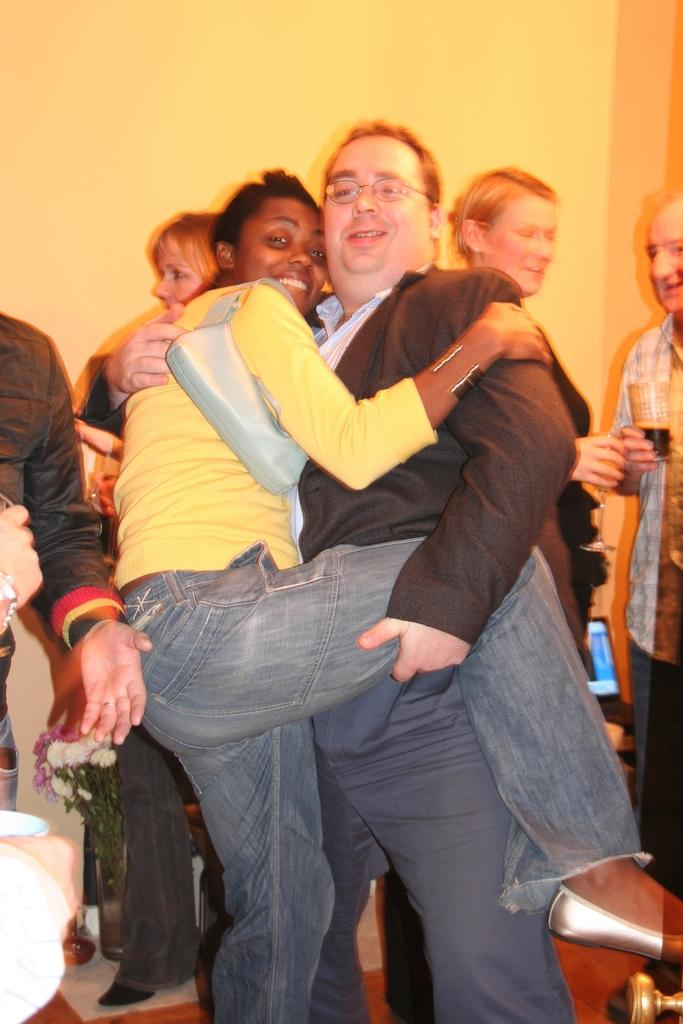What is the woman in the image wearing? The woman is wearing a yellow t-shirt and jeans. What is the woman doing in the image? The woman is holding a man in the image. What is the man wearing in the image? The man is wearing a black suit. What are the people in the background of the image doing? The people in the background are drinking wine. What is visible in the background of the image? There is a wall in the background of the image. What invention can be seen in the woman's hand in the image? There is no invention visible in the woman's hand in the image; she is holding a man. What type of curve is present in the image? There is no curve mentioned or visible in the image. 